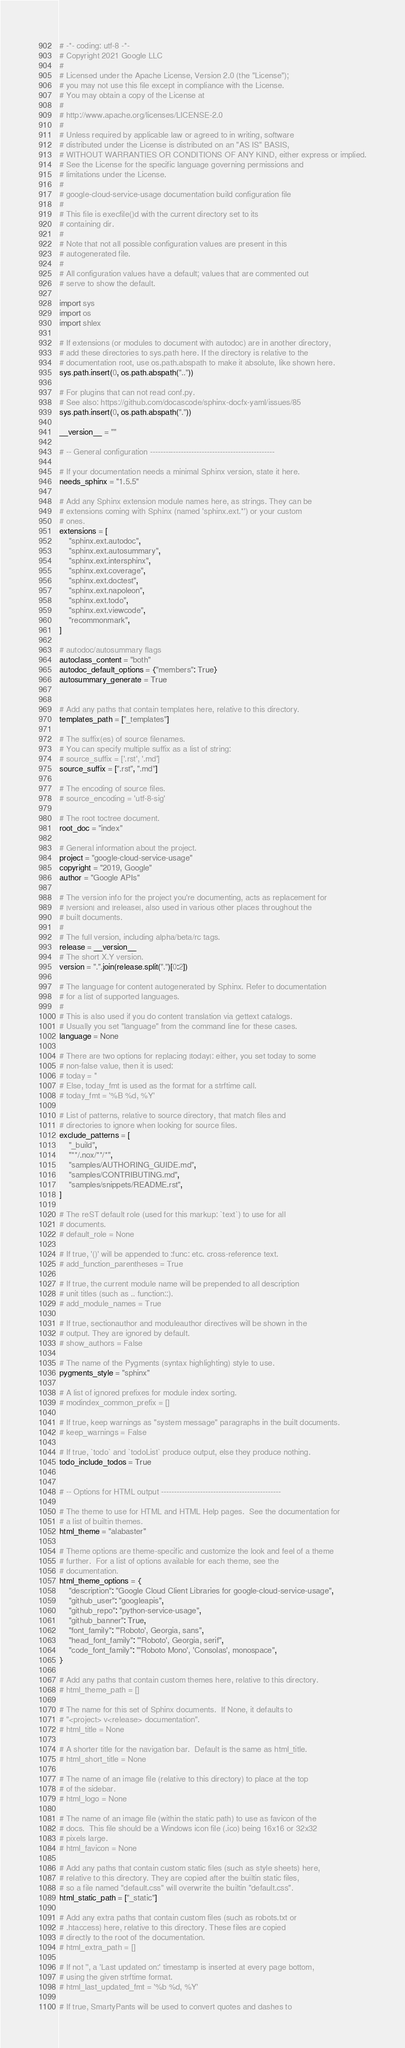Convert code to text. <code><loc_0><loc_0><loc_500><loc_500><_Python_># -*- coding: utf-8 -*-
# Copyright 2021 Google LLC
#
# Licensed under the Apache License, Version 2.0 (the "License");
# you may not use this file except in compliance with the License.
# You may obtain a copy of the License at
#
# http://www.apache.org/licenses/LICENSE-2.0
#
# Unless required by applicable law or agreed to in writing, software
# distributed under the License is distributed on an "AS IS" BASIS,
# WITHOUT WARRANTIES OR CONDITIONS OF ANY KIND, either express or implied.
# See the License for the specific language governing permissions and
# limitations under the License.
#
# google-cloud-service-usage documentation build configuration file
#
# This file is execfile()d with the current directory set to its
# containing dir.
#
# Note that not all possible configuration values are present in this
# autogenerated file.
#
# All configuration values have a default; values that are commented out
# serve to show the default.

import sys
import os
import shlex

# If extensions (or modules to document with autodoc) are in another directory,
# add these directories to sys.path here. If the directory is relative to the
# documentation root, use os.path.abspath to make it absolute, like shown here.
sys.path.insert(0, os.path.abspath(".."))

# For plugins that can not read conf.py.
# See also: https://github.com/docascode/sphinx-docfx-yaml/issues/85
sys.path.insert(0, os.path.abspath("."))

__version__ = ""

# -- General configuration ------------------------------------------------

# If your documentation needs a minimal Sphinx version, state it here.
needs_sphinx = "1.5.5"

# Add any Sphinx extension module names here, as strings. They can be
# extensions coming with Sphinx (named 'sphinx.ext.*') or your custom
# ones.
extensions = [
    "sphinx.ext.autodoc",
    "sphinx.ext.autosummary",
    "sphinx.ext.intersphinx",
    "sphinx.ext.coverage",
    "sphinx.ext.doctest",
    "sphinx.ext.napoleon",
    "sphinx.ext.todo",
    "sphinx.ext.viewcode",
    "recommonmark",
]

# autodoc/autosummary flags
autoclass_content = "both"
autodoc_default_options = {"members": True}
autosummary_generate = True


# Add any paths that contain templates here, relative to this directory.
templates_path = ["_templates"]

# The suffix(es) of source filenames.
# You can specify multiple suffix as a list of string:
# source_suffix = ['.rst', '.md']
source_suffix = [".rst", ".md"]

# The encoding of source files.
# source_encoding = 'utf-8-sig'

# The root toctree document.
root_doc = "index"

# General information about the project.
project = "google-cloud-service-usage"
copyright = "2019, Google"
author = "Google APIs"

# The version info for the project you're documenting, acts as replacement for
# |version| and |release|, also used in various other places throughout the
# built documents.
#
# The full version, including alpha/beta/rc tags.
release = __version__
# The short X.Y version.
version = ".".join(release.split(".")[0:2])

# The language for content autogenerated by Sphinx. Refer to documentation
# for a list of supported languages.
#
# This is also used if you do content translation via gettext catalogs.
# Usually you set "language" from the command line for these cases.
language = None

# There are two options for replacing |today|: either, you set today to some
# non-false value, then it is used:
# today = ''
# Else, today_fmt is used as the format for a strftime call.
# today_fmt = '%B %d, %Y'

# List of patterns, relative to source directory, that match files and
# directories to ignore when looking for source files.
exclude_patterns = [
    "_build",
    "**/.nox/**/*",
    "samples/AUTHORING_GUIDE.md",
    "samples/CONTRIBUTING.md",
    "samples/snippets/README.rst",
]

# The reST default role (used for this markup: `text`) to use for all
# documents.
# default_role = None

# If true, '()' will be appended to :func: etc. cross-reference text.
# add_function_parentheses = True

# If true, the current module name will be prepended to all description
# unit titles (such as .. function::).
# add_module_names = True

# If true, sectionauthor and moduleauthor directives will be shown in the
# output. They are ignored by default.
# show_authors = False

# The name of the Pygments (syntax highlighting) style to use.
pygments_style = "sphinx"

# A list of ignored prefixes for module index sorting.
# modindex_common_prefix = []

# If true, keep warnings as "system message" paragraphs in the built documents.
# keep_warnings = False

# If true, `todo` and `todoList` produce output, else they produce nothing.
todo_include_todos = True


# -- Options for HTML output ----------------------------------------------

# The theme to use for HTML and HTML Help pages.  See the documentation for
# a list of builtin themes.
html_theme = "alabaster"

# Theme options are theme-specific and customize the look and feel of a theme
# further.  For a list of options available for each theme, see the
# documentation.
html_theme_options = {
    "description": "Google Cloud Client Libraries for google-cloud-service-usage",
    "github_user": "googleapis",
    "github_repo": "python-service-usage",
    "github_banner": True,
    "font_family": "'Roboto', Georgia, sans",
    "head_font_family": "'Roboto', Georgia, serif",
    "code_font_family": "'Roboto Mono', 'Consolas', monospace",
}

# Add any paths that contain custom themes here, relative to this directory.
# html_theme_path = []

# The name for this set of Sphinx documents.  If None, it defaults to
# "<project> v<release> documentation".
# html_title = None

# A shorter title for the navigation bar.  Default is the same as html_title.
# html_short_title = None

# The name of an image file (relative to this directory) to place at the top
# of the sidebar.
# html_logo = None

# The name of an image file (within the static path) to use as favicon of the
# docs.  This file should be a Windows icon file (.ico) being 16x16 or 32x32
# pixels large.
# html_favicon = None

# Add any paths that contain custom static files (such as style sheets) here,
# relative to this directory. They are copied after the builtin static files,
# so a file named "default.css" will overwrite the builtin "default.css".
html_static_path = ["_static"]

# Add any extra paths that contain custom files (such as robots.txt or
# .htaccess) here, relative to this directory. These files are copied
# directly to the root of the documentation.
# html_extra_path = []

# If not '', a 'Last updated on:' timestamp is inserted at every page bottom,
# using the given strftime format.
# html_last_updated_fmt = '%b %d, %Y'

# If true, SmartyPants will be used to convert quotes and dashes to</code> 